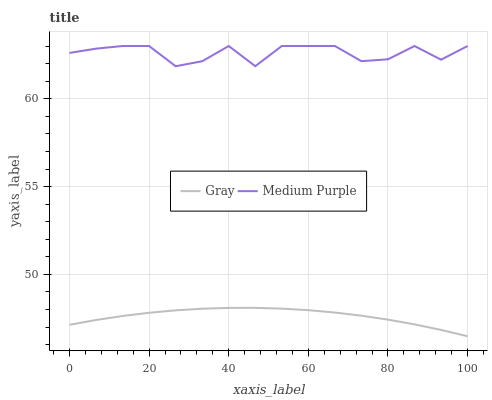Does Gray have the minimum area under the curve?
Answer yes or no. Yes. Does Medium Purple have the maximum area under the curve?
Answer yes or no. Yes. Does Gray have the maximum area under the curve?
Answer yes or no. No. Is Gray the smoothest?
Answer yes or no. Yes. Is Medium Purple the roughest?
Answer yes or no. Yes. Is Gray the roughest?
Answer yes or no. No. Does Gray have the lowest value?
Answer yes or no. Yes. Does Medium Purple have the highest value?
Answer yes or no. Yes. Does Gray have the highest value?
Answer yes or no. No. Is Gray less than Medium Purple?
Answer yes or no. Yes. Is Medium Purple greater than Gray?
Answer yes or no. Yes. Does Gray intersect Medium Purple?
Answer yes or no. No. 